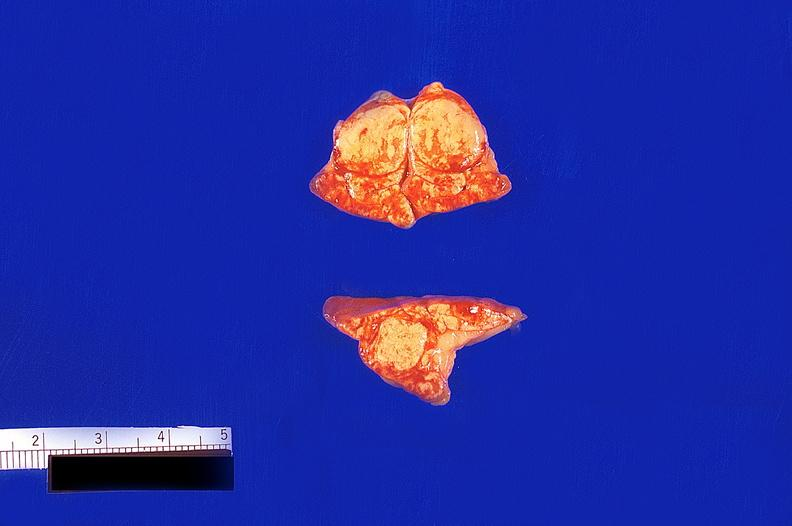does this image show adrenal gland, cortical nodular hyperplasia?
Answer the question using a single word or phrase. Yes 